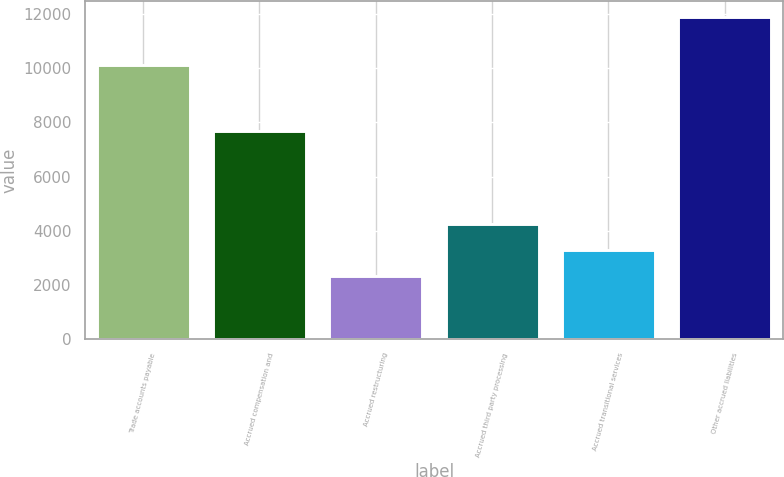Convert chart. <chart><loc_0><loc_0><loc_500><loc_500><bar_chart><fcel>Trade accounts payable<fcel>Accrued compensation and<fcel>Accrued restructuring<fcel>Accrued third party processing<fcel>Accrued transitional services<fcel>Other accrued liabilities<nl><fcel>10133<fcel>7667<fcel>2347<fcel>4252.4<fcel>3299.7<fcel>11874<nl></chart> 